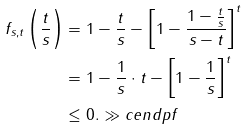<formula> <loc_0><loc_0><loc_500><loc_500>f _ { s , t } \left ( \frac { t } { s } \right ) & = 1 - \frac { t } { s } - \left [ 1 - \frac { 1 - \frac { t } { s } } { s - t } \right ] ^ { t } \\ & = 1 - \frac { 1 } { s } \cdot t - \left [ 1 - \frac { 1 } { s } \right ] ^ { t } \\ & \leq 0 . \gg c e n d p f</formula> 